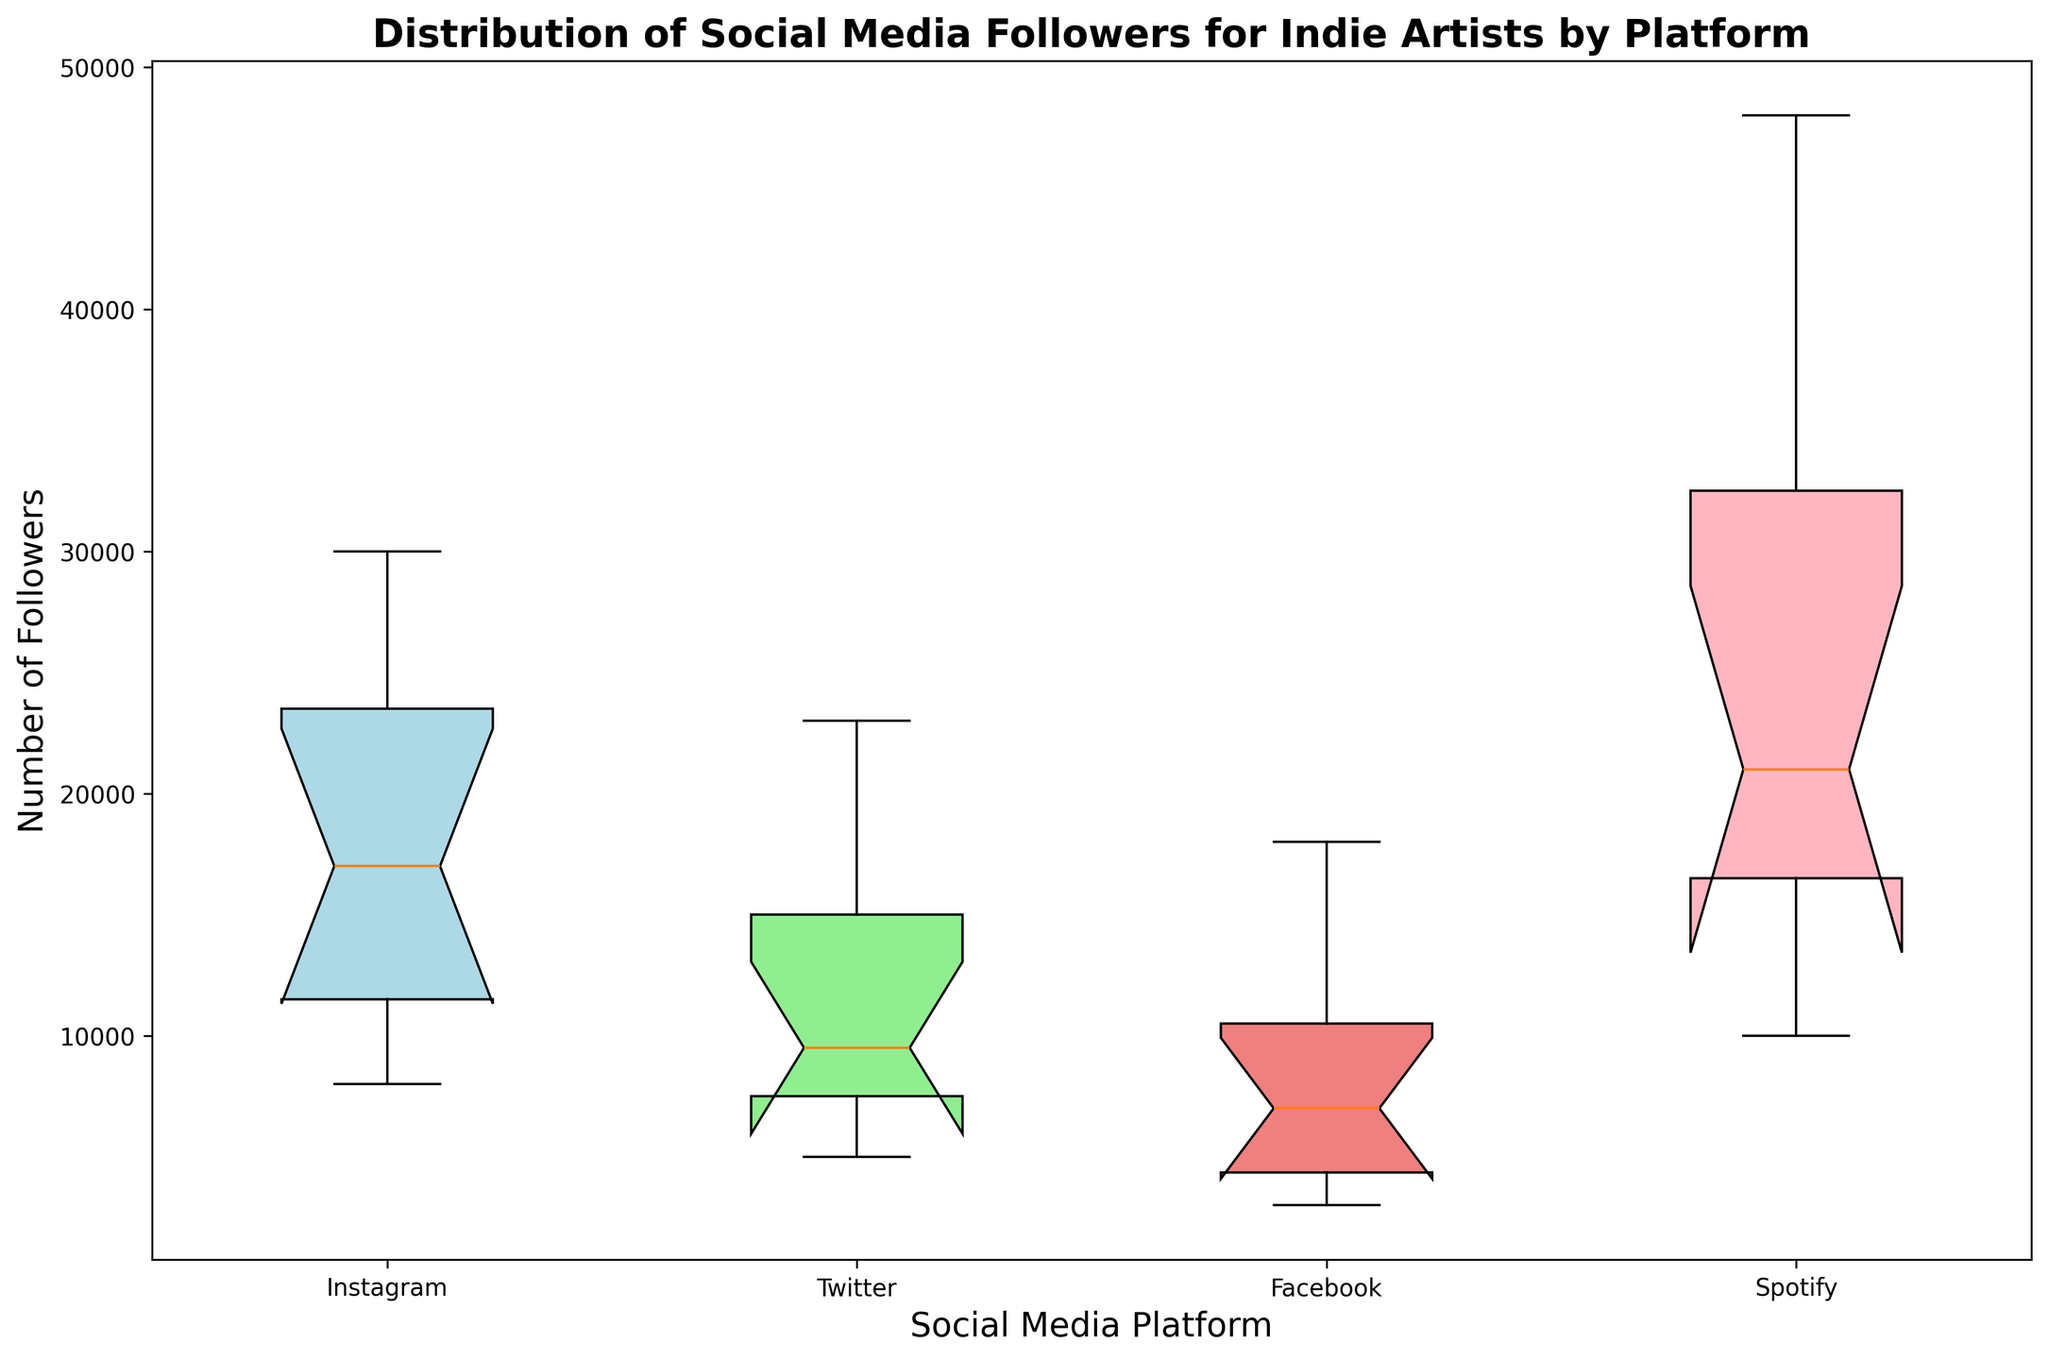Which platform has the highest median number of followers? By analyzing the box plot, identify the platform with the highest horizontal line inside the box indicating the median.
Answer: Spotify Which platform has the lowest median number of followers? Look at the box plot to find the platform with the lowest horizontal line inside the box, representing the median.
Answer: Facebook What is the interquartile range (IQR) for Instagram's followers? Determine the difference between the upper (Q3) and lower (Q1) quartiles for Instagram by identifying the top and bottom edges of the box in the plot.
Answer: Upper Quartile (Q3) - Lower Quartile (Q1) Which platform shows the most variation in the number of followers? Find the box with the greatest height, as this indicates the most variability in the dataset.
Answer: Spotify Compare the median followers of JayWood on Instagram and Facebook. Which is higher? Locate the medians for JayWood on both Instagram and Facebook as represented by the horizontal lines inside the boxes. Compare their positions.
Answer: Instagram Does Twitter have any outliers in its follower distribution? Examine the Twitter box plot for any dots outside the whiskers, which represent outliers.
Answer: No Which platform seems to be skewed, and in which direction? Assess the skewness by observing the whiskers and the median line's position within the boxes. A longer whisker on one side of the median indicates the direction.
Answer: Facebook, right-skewed What is the median number of followers for JayWood across all platforms? Locate the medians for each platform for JayWood and calculate their median value.
Answer: 11500 On which platform does the distribution of followers for indie artists appear most consistent? Look for the box plot with the smallest IQR (smallest box), indicating consistent or less variable data.
Answer: Twitter For artists with the highest number of followers on Spotify, are their Instagram follower counts also high? Compare the box plots of these two platforms, focusing on the upper quartiles (Q3) and maximum values.
Answer: Yes 